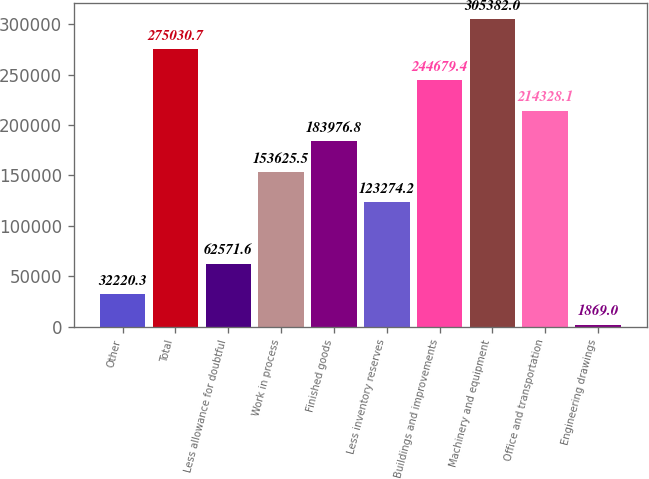<chart> <loc_0><loc_0><loc_500><loc_500><bar_chart><fcel>Other<fcel>Total<fcel>Less allowance for doubtful<fcel>Work in process<fcel>Finished goods<fcel>Less inventory reserves<fcel>Buildings and improvements<fcel>Machinery and equipment<fcel>Office and transportation<fcel>Engineering drawings<nl><fcel>32220.3<fcel>275031<fcel>62571.6<fcel>153626<fcel>183977<fcel>123274<fcel>244679<fcel>305382<fcel>214328<fcel>1869<nl></chart> 